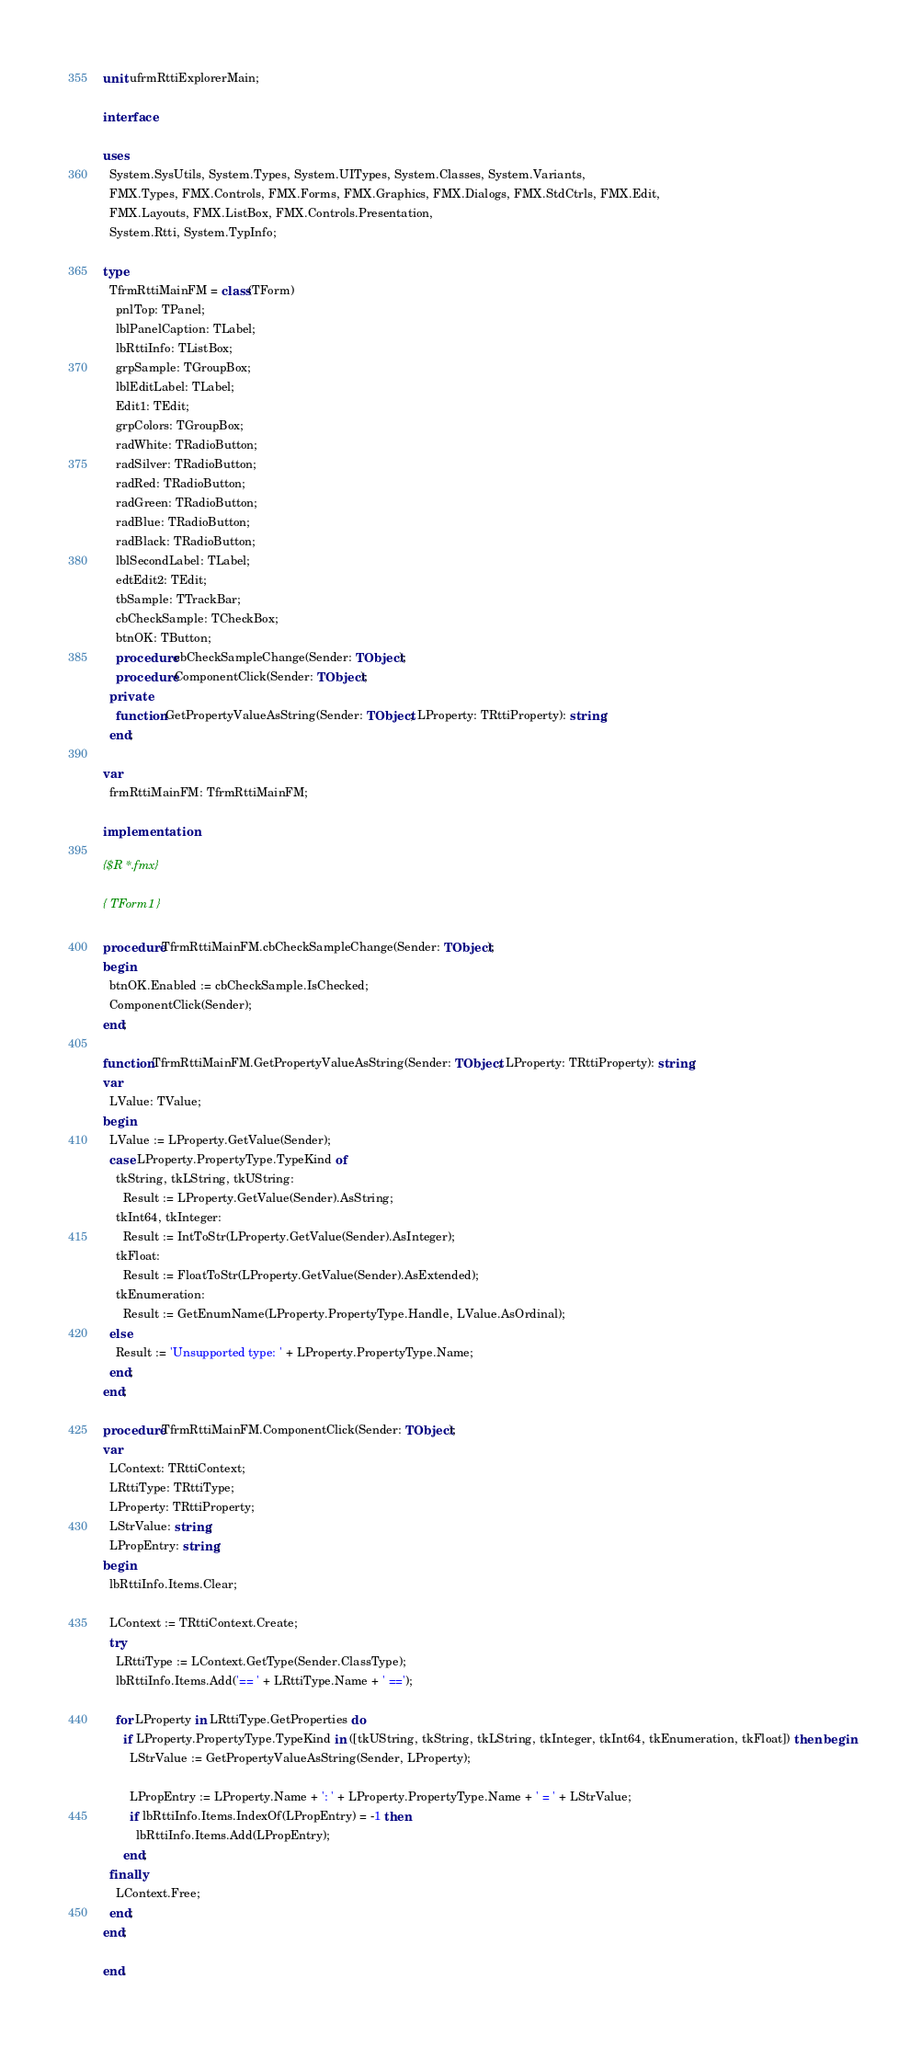Convert code to text. <code><loc_0><loc_0><loc_500><loc_500><_Pascal_>unit ufrmRttiExplorerMain;

interface

uses
  System.SysUtils, System.Types, System.UITypes, System.Classes, System.Variants,
  FMX.Types, FMX.Controls, FMX.Forms, FMX.Graphics, FMX.Dialogs, FMX.StdCtrls, FMX.Edit,
  FMX.Layouts, FMX.ListBox, FMX.Controls.Presentation,
  System.Rtti, System.TypInfo;

type
  TfrmRttiMainFM = class(TForm)
    pnlTop: TPanel;
    lblPanelCaption: TLabel;
    lbRttiInfo: TListBox;
    grpSample: TGroupBox;
    lblEditLabel: TLabel;
    Edit1: TEdit;
    grpColors: TGroupBox;
    radWhite: TRadioButton;
    radSilver: TRadioButton;
    radRed: TRadioButton;
    radGreen: TRadioButton;
    radBlue: TRadioButton;
    radBlack: TRadioButton;
    lblSecondLabel: TLabel;
    edtEdit2: TEdit;
    tbSample: TTrackBar;
    cbCheckSample: TCheckBox;
    btnOK: TButton;
    procedure cbCheckSampleChange(Sender: TObject);
    procedure ComponentClick(Sender: TObject);
  private
    function GetPropertyValueAsString(Sender: TObject; LProperty: TRttiProperty): string;
  end;

var
  frmRttiMainFM: TfrmRttiMainFM;

implementation

{$R *.fmx}

{ TForm1 }

procedure TfrmRttiMainFM.cbCheckSampleChange(Sender: TObject);
begin
  btnOK.Enabled := cbCheckSample.IsChecked;
  ComponentClick(Sender);
end;

function TfrmRttiMainFM.GetPropertyValueAsString(Sender: TObject; LProperty: TRttiProperty): string;
var
  LValue: TValue;
begin
  LValue := LProperty.GetValue(Sender);
  case LProperty.PropertyType.TypeKind of
    tkString, tkLString, tkUString:
      Result := LProperty.GetValue(Sender).AsString;
    tkInt64, tkInteger:
      Result := IntToStr(LProperty.GetValue(Sender).AsInteger);
    tkFloat:
      Result := FloatToStr(LProperty.GetValue(Sender).AsExtended);
    tkEnumeration:
      Result := GetEnumName(LProperty.PropertyType.Handle, LValue.AsOrdinal);
  else
    Result := 'Unsupported type: ' + LProperty.PropertyType.Name;
  end;
end;

procedure TfrmRttiMainFM.ComponentClick(Sender: TObject);
var
  LContext: TRttiContext;
  LRttiType: TRttiType;
  LProperty: TRttiProperty;
  LStrValue: string;
  LPropEntry: string;
begin
  lbRttiInfo.Items.Clear;

  LContext := TRttiContext.Create;
  try
    LRttiType := LContext.GetType(Sender.ClassType);
    lbRttiInfo.Items.Add('== ' + LRttiType.Name + ' ==');

    for LProperty in LRttiType.GetProperties do
      if LProperty.PropertyType.TypeKind in ([tkUString, tkString, tkLString, tkInteger, tkInt64, tkEnumeration, tkFloat]) then begin
        LStrValue := GetPropertyValueAsString(Sender, LProperty);

        LPropEntry := LProperty.Name + ': ' + LProperty.PropertyType.Name + ' = ' + LStrValue;
        if lbRttiInfo.Items.IndexOf(LPropEntry) = -1 then
          lbRttiInfo.Items.Add(LPropEntry);
      end;
  finally
    LContext.Free;
  end;
end;

end.
</code> 